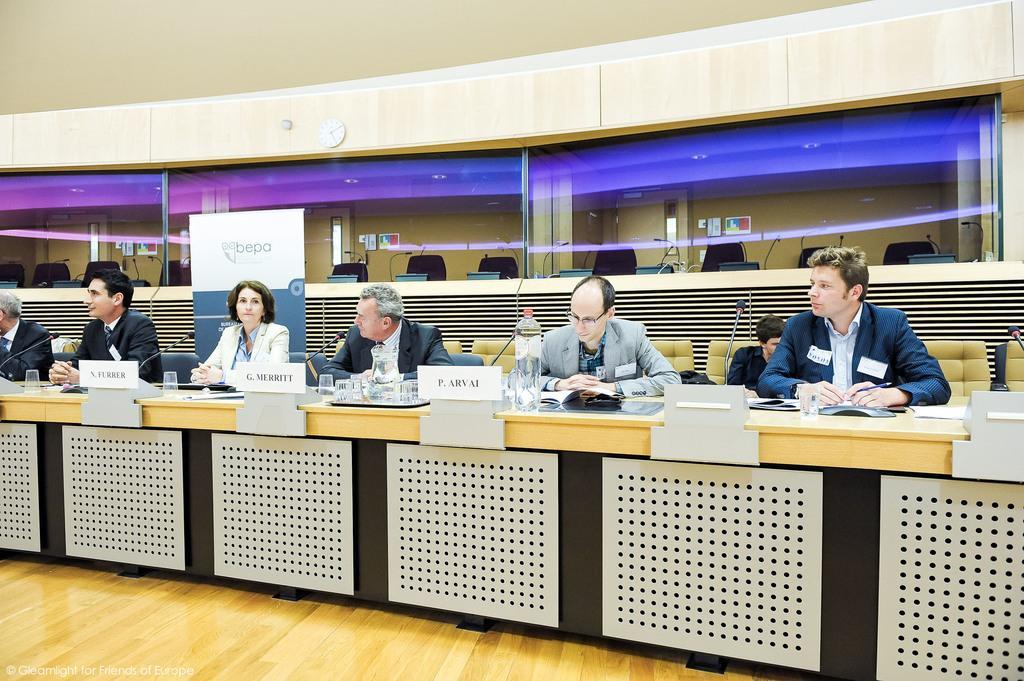Please provide a concise description of this image. In the image we can see there are people sitting on the chair and glasses kept on the tray. There is mic kept on the stand and behind there is banner kept on the ground. 